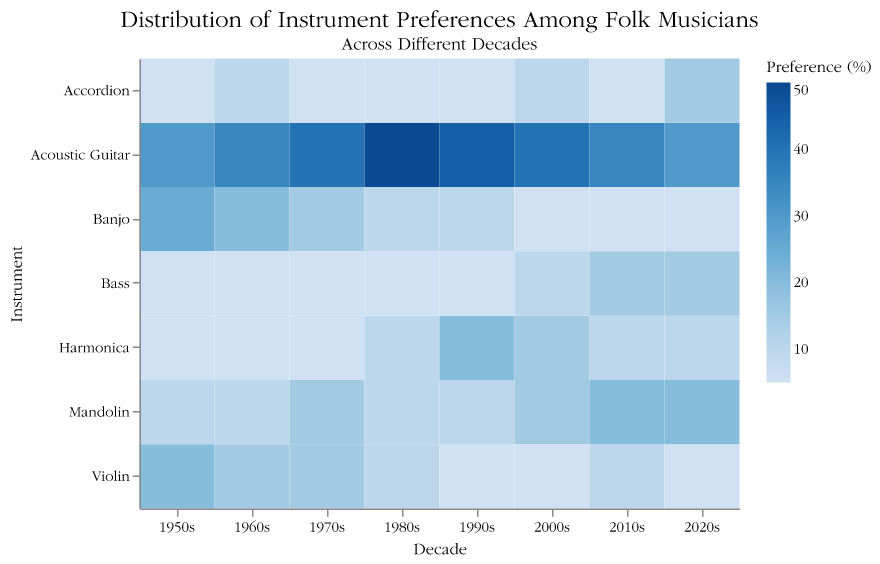Which instrument saw its highest preference in the 1980s? The highest heatmap value in the 1980s row is 50 for Acoustic Guitar, indicating its highest preference during that decade.
Answer: Acoustic Guitar From 1950s to 2020s, how did the preference for the Mandolin change? By comparing the Mandolin preferences from each decade, they rise from 10 in the 1950s, remain at 10 in the 1960s, increase to 15 in the 1970s, drop to 10 in the 1980s, stay at 10 in the 1990s, increase to 15 in the 2000s, and peak at 20 in both the 2010s and 2020s.
Answer: Increased Which decade had the least number of instruments with preferences above 20%? The heatmap shows only the 1950s (one instrument, Acoustic Guitar) and the decades from the 1980s to 2020s (one or none) had instruments above 20%.
Answer: 1960s-2020s Comparing the 1970s and 2000s, which had a higher preference for Banjo? Observing the Banjo row, the 1970s show a preference of 15%, while the 2000s show a preference of 5%.
Answer: 1970s How does the preference for the Harmonica trend across decades? Observing the Harmonica row, the preference stays at 5% from 1950s to 1970s, spikes to 10% in the 1980s, rises sharply to 20% in the 1990s, settles at 15% in the 2000s, slightly drops to 10% in the 2010s and 2020s.
Answer: Peaks in 1990s Which instrument shows the greatest increase in preference from the 1990s to the 2020s? By comparing the preferences between these decades, the Bass shows an increase from 5% to 15%, a 10% rise.
Answer: Bass During which decade was the preference for the Accordion highest? By checking the Accordion row, the highest value of 15% appears in the 2020s.
Answer: 2020s Is the preference for Acoustic Guitar consistently the highest across the decades? The Acoustic Guitar has the highest values in all decades as shown in the heatmap when compared to other instruments.
Answer: Yes What is the combined preference percentage for Violin and Mandolin in the 1950s? In the 1950s row, Violin has 20% and Mandolin has 10%. Their combined preference is 20 + 10 = 30%.
Answer: 30% Which decade has the most balanced preference among instruments (least variance)? The 1980s row, where Acoustic Guitar is 50% and the rest are 5-10%, shows more even distribution compared to other decades with wider spreads in values.
Answer: 1980s 